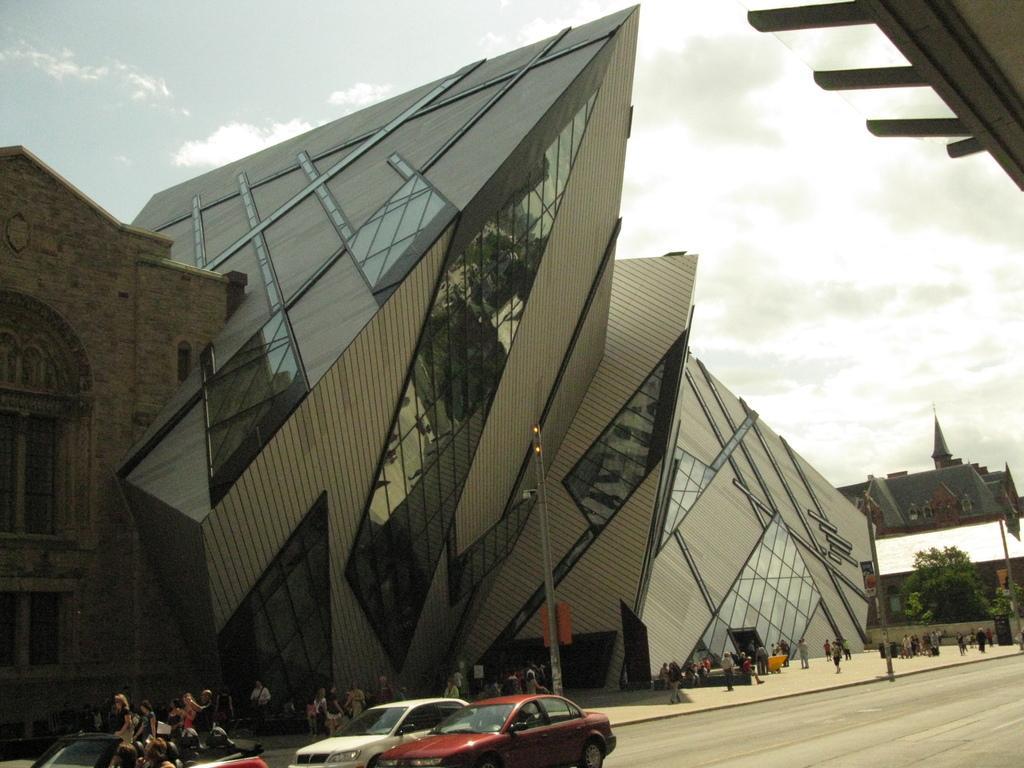Can you describe this image briefly? In the foreground I can see three cars and a crowd on the road. In the background I can see light poles, buildings, glass, windows, trees, fence, chairs and the sky. This image is taken may be during a day. 